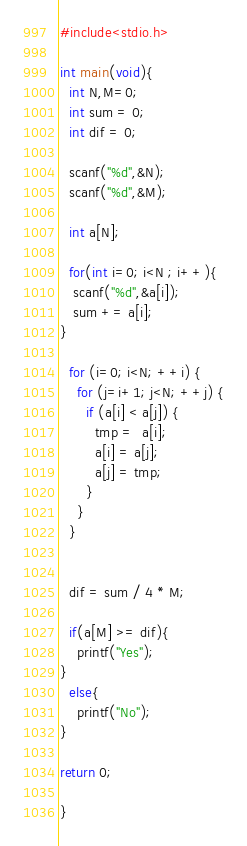Convert code to text. <code><loc_0><loc_0><loc_500><loc_500><_C_>#include<stdio.h>
 
int main(void){
  int N,M=0;
  int sum = 0;
  int dif = 0;

  scanf("%d",&N);
  scanf("%d",&M);

  int a[N];
  
  for(int i=0; i<N ; i++){
   scanf("%d",&a[i]);
   sum += a[i];
}

  for (i=0; i<N; ++i) {
    for (j=i+1; j<N; ++j) {
      if (a[i] < a[j]) {
        tmp =  a[i];
        a[i] = a[j];
        a[j] = tmp;
      }
    }
  }


  dif = sum / 4 * M;

  if(a[M] >= dif){
    printf("Yes");
}
  else{
    printf("No");
}

return 0;
 
}</code> 